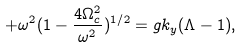<formula> <loc_0><loc_0><loc_500><loc_500>+ \omega ^ { 2 } ( 1 - \frac { 4 \Omega _ { c } ^ { 2 } } { \omega ^ { 2 } } ) ^ { 1 / 2 } = g k _ { y } ( \Lambda - 1 ) ,</formula> 